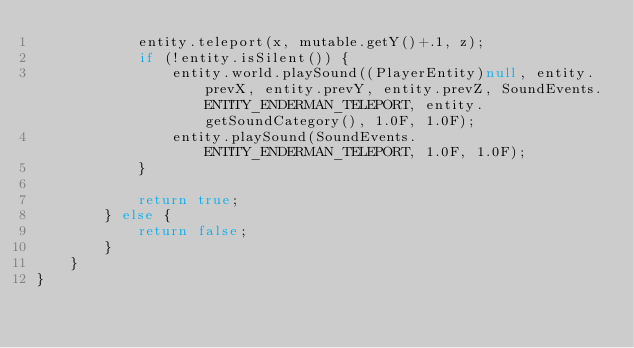<code> <loc_0><loc_0><loc_500><loc_500><_Java_>            entity.teleport(x, mutable.getY()+.1, z);
            if (!entity.isSilent()) {
                entity.world.playSound((PlayerEntity)null, entity.prevX, entity.prevY, entity.prevZ, SoundEvents.ENTITY_ENDERMAN_TELEPORT, entity.getSoundCategory(), 1.0F, 1.0F);
                entity.playSound(SoundEvents.ENTITY_ENDERMAN_TELEPORT, 1.0F, 1.0F);
            }

            return true;
        } else {
            return false;
        }
    }
}
</code> 